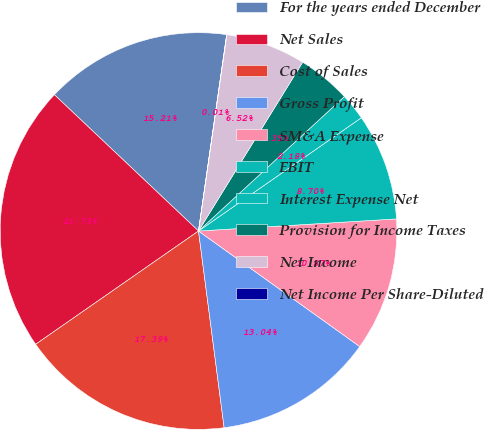Convert chart. <chart><loc_0><loc_0><loc_500><loc_500><pie_chart><fcel>For the years ended December<fcel>Net Sales<fcel>Cost of Sales<fcel>Gross Profit<fcel>SM&A Expense<fcel>EBIT<fcel>Interest Expense Net<fcel>Provision for Income Taxes<fcel>Net Income<fcel>Net Income Per Share-Diluted<nl><fcel>15.21%<fcel>21.73%<fcel>17.39%<fcel>13.04%<fcel>10.87%<fcel>8.7%<fcel>2.18%<fcel>4.35%<fcel>6.52%<fcel>0.01%<nl></chart> 